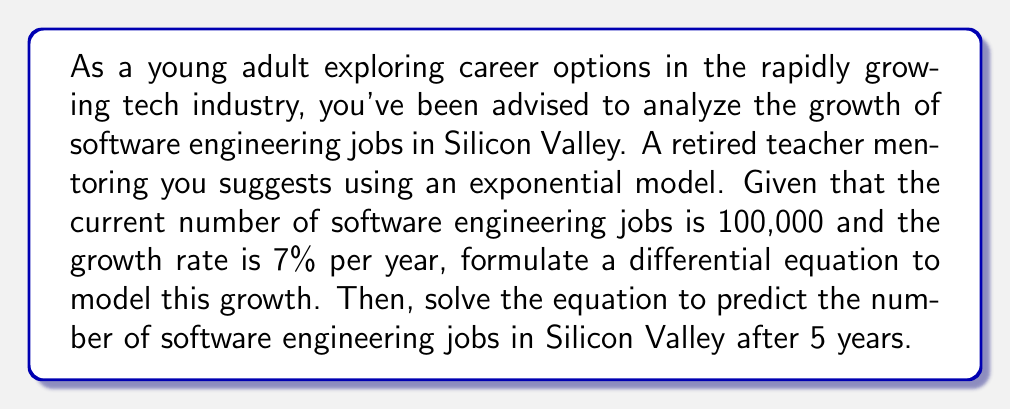Can you answer this question? Let's approach this step-by-step:

1) Let $N(t)$ be the number of software engineering jobs at time $t$, where $t$ is measured in years.

2) The rate of change of jobs with respect to time is proportional to the current number of jobs. This can be expressed as:

   $$\frac{dN}{dt} = kN$$

   where $k$ is the growth rate constant.

3) We're given that the growth rate is 7% per year, so $k = 0.07$.

4) Now our differential equation is:

   $$\frac{dN}{dt} = 0.07N$$

5) This is a separable differential equation. Let's solve it:

   $$\frac{dN}{N} = 0.07dt$$

6) Integrating both sides:

   $$\int \frac{dN}{N} = \int 0.07dt$$

   $$\ln|N| = 0.07t + C$$

7) Taking the exponential of both sides:

   $$N = e^{0.07t + C} = e^C \cdot e^{0.07t}$$

8) Let $A = e^C$. Then our general solution is:

   $$N(t) = A \cdot e^{0.07t}$$

9) We're given that $N(0) = 100,000$. Let's use this initial condition:

   $$100,000 = A \cdot e^{0.07 \cdot 0} = A$$

10) So our particular solution is:

    $$N(t) = 100,000 \cdot e^{0.07t}$$

11) To find the number of jobs after 5 years, we calculate $N(5)$:

    $$N(5) = 100,000 \cdot e^{0.07 \cdot 5} \approx 141,907$$

Therefore, after 5 years, there will be approximately 141,907 software engineering jobs in Silicon Valley according to this model.
Answer: After 5 years, there will be approximately 141,907 software engineering jobs in Silicon Valley. 